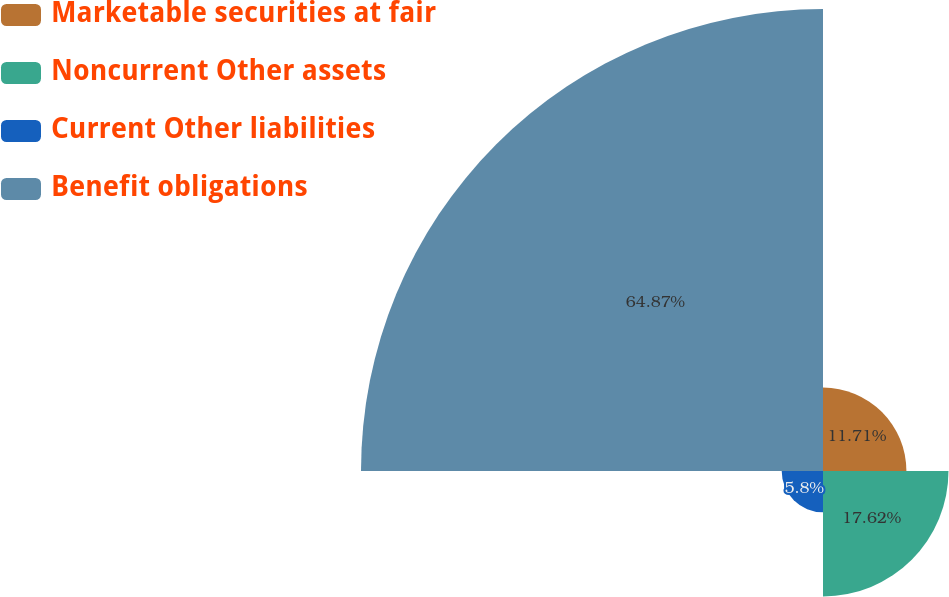<chart> <loc_0><loc_0><loc_500><loc_500><pie_chart><fcel>Marketable securities at fair<fcel>Noncurrent Other assets<fcel>Current Other liabilities<fcel>Benefit obligations<nl><fcel>11.71%<fcel>17.62%<fcel>5.8%<fcel>64.87%<nl></chart> 